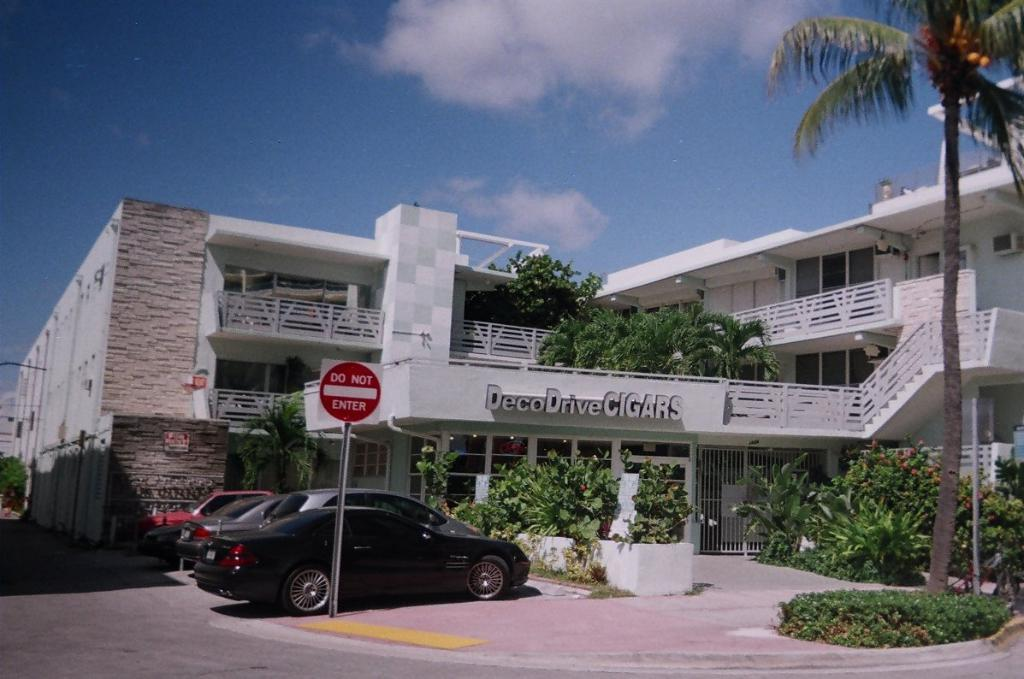What is on the pole in the image? There is a board on a pole in the image. What type of vegetation can be seen in the image? There are plants and a tree in the image. What type of structure is visible in the image? There is a building in the image. What type of transportation is visible on the surface in the image? There are vehicles visible on the surface in the image. What is visible in the sky in the image? The sky is visible in the image. Can you tell me how many friends are sitting on the tree in the image? There are no friends sitting on the tree in the image; it is a tree with no people present. What type of vegetable is growing on the board in the image? There are no vegetables growing on the board in the image; it is a board on a pole with no plants or vegetables present. 